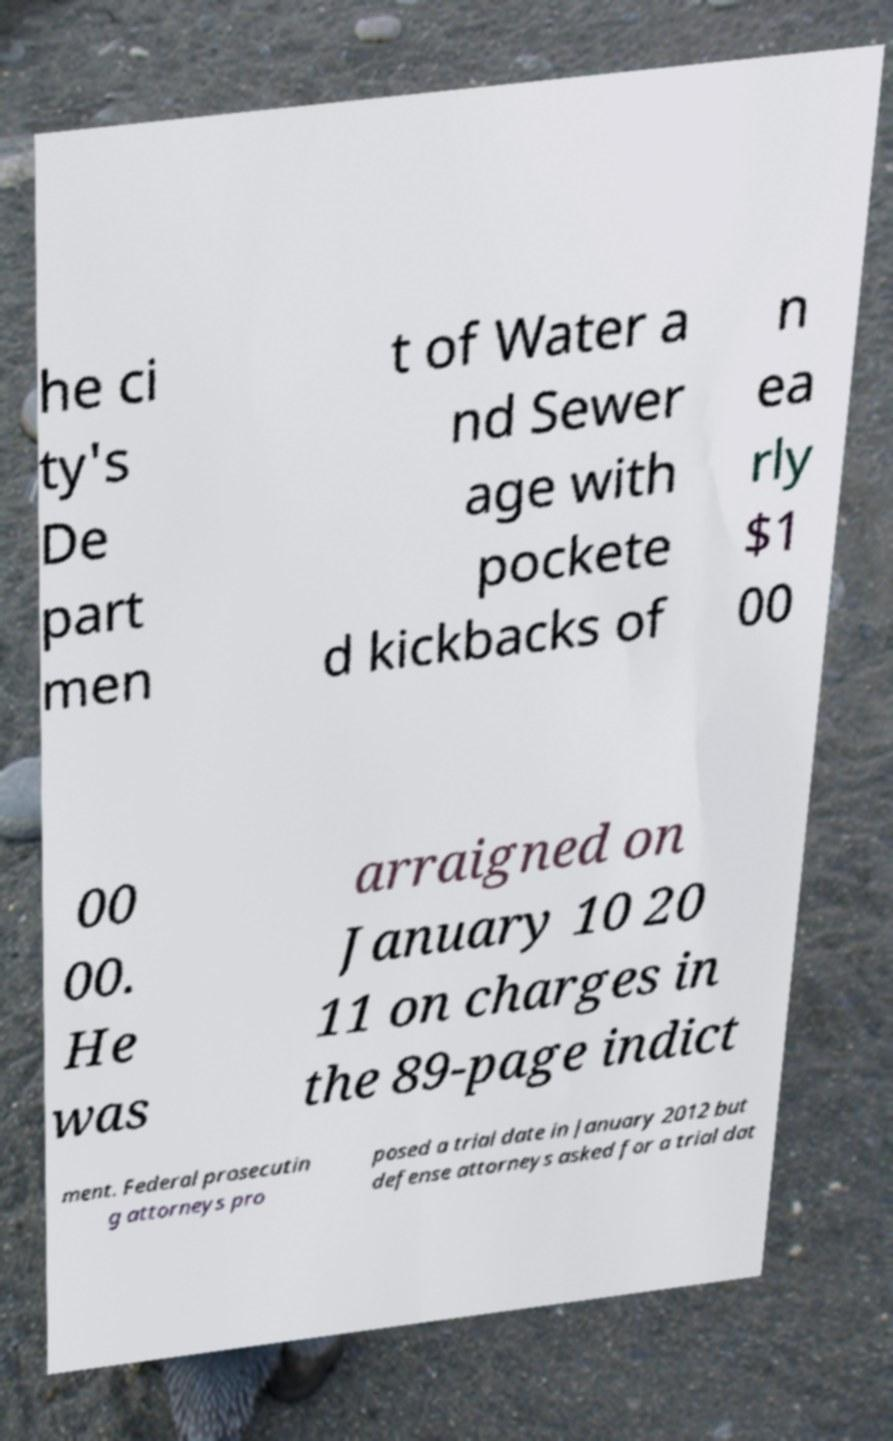What messages or text are displayed in this image? I need them in a readable, typed format. he ci ty's De part men t of Water a nd Sewer age with pockete d kickbacks of n ea rly $1 00 00 00. He was arraigned on January 10 20 11 on charges in the 89-page indict ment. Federal prosecutin g attorneys pro posed a trial date in January 2012 but defense attorneys asked for a trial dat 